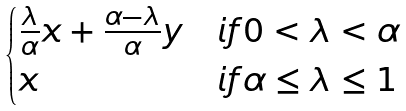<formula> <loc_0><loc_0><loc_500><loc_500>\begin{cases} \frac { \lambda } { \alpha } x + \frac { \alpha - \lambda } { \alpha } y & i f 0 < \lambda < \alpha \\ x & i f \alpha \leq \lambda \leq 1 \end{cases}</formula> 